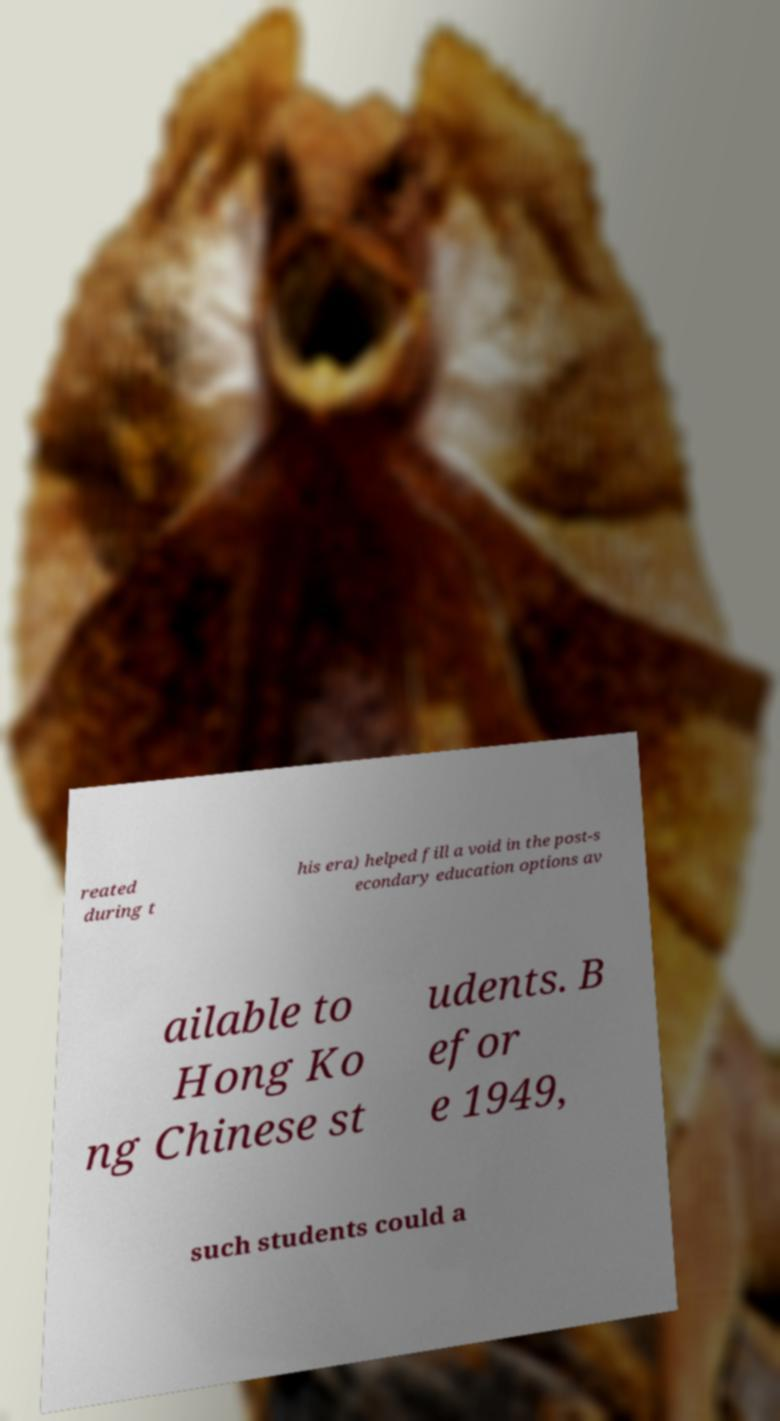Please read and relay the text visible in this image. What does it say? reated during t his era) helped fill a void in the post-s econdary education options av ailable to Hong Ko ng Chinese st udents. B efor e 1949, such students could a 